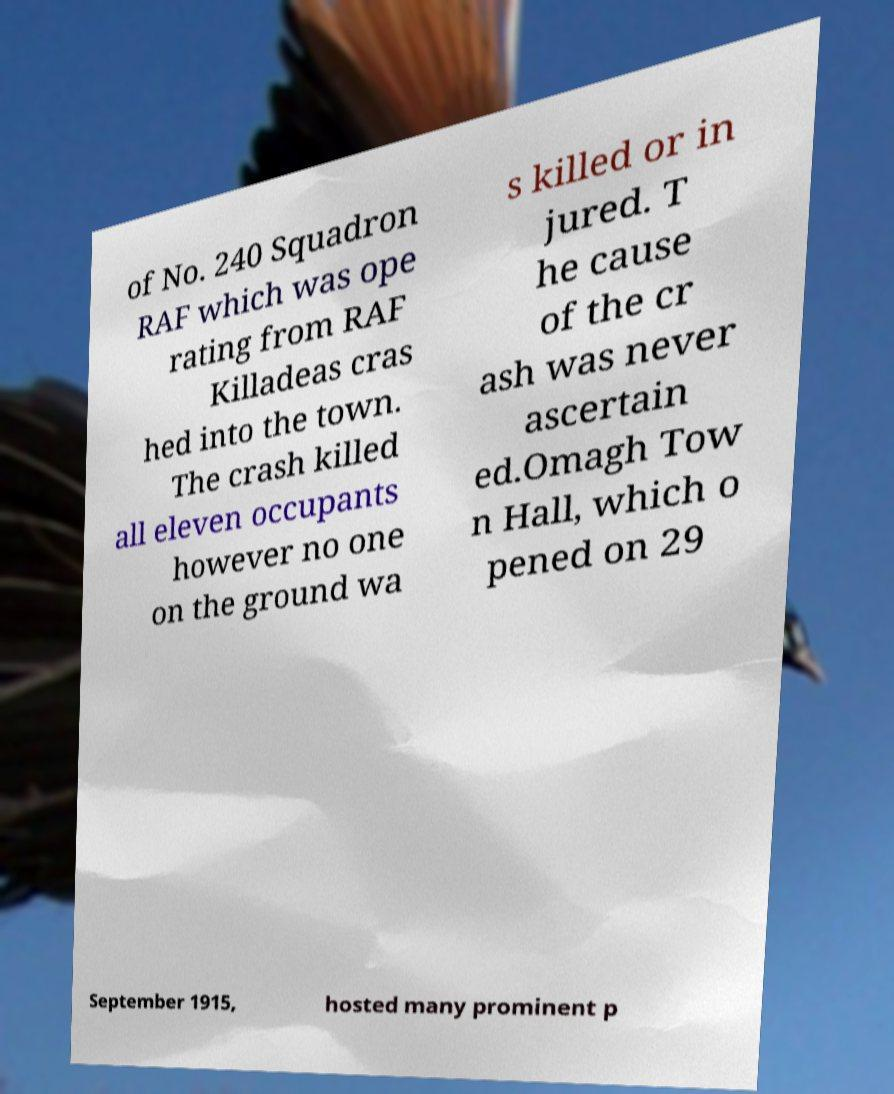Can you accurately transcribe the text from the provided image for me? of No. 240 Squadron RAF which was ope rating from RAF Killadeas cras hed into the town. The crash killed all eleven occupants however no one on the ground wa s killed or in jured. T he cause of the cr ash was never ascertain ed.Omagh Tow n Hall, which o pened on 29 September 1915, hosted many prominent p 